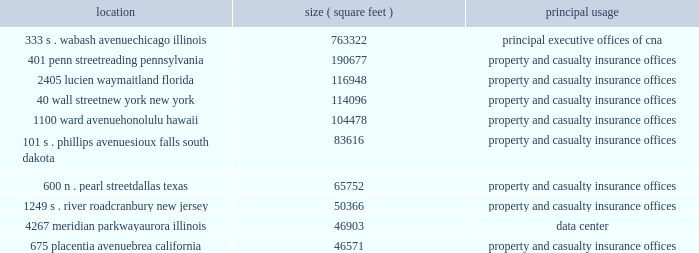Item 1 .
Business cna financial corporation 2013 ( continued ) unpredictability in the law , insurance underwriting is expected to continue to be difficult in commercial lines , professional liability and other specialty coverages .
The dodd-frank wall street reform and consumer protection act expands the federal presence in insurance oversight and may increase the regulatory requirements to which cna may be subject .
The act 2019s requirements include streamlining the state-based regulation of reinsurance and nonadmitted insurance ( property or casualty insurance placed from insurers that are eligible to accept insurance , but are not licensed to write insurance in a particular state ) .
The act also establishes a new federal insurance office within the u.s .
Department of the treasury with powers over all lines of insurance except health insurance , certain long term care insurance and crop insurance , to , among other things , monitor aspects of the insurance industry , identify issues in the regulation of insurers that could contribute to a systemic crisis in the insurance industry or the overall financial system , coordinate federal policy on international insurance matters and preempt state insurance measures under certain circumstances .
The act calls for numerous studies and contemplates further regulation .
The patient protection and affordable care act and the related amendments in the health care and education reconciliation act may increase cna 2019s operating costs and underwriting losses .
This landmark legislation may lead to numerous changes in the health care industry that could create additional operating costs for cna , particularly with respect to workers 2019 compensation and long term care products .
These costs might arise through the increased use of health care services by claimants or the increased complexities in health care bills that could require additional levels of review .
In addition , due to the expected number of new participants in the health care system and the potential for additional malpractice claims , cna may experience increased underwriting risk in the lines of business that provide management and professional liability insurance to individuals and businesses engaged in the health care industry .
The lines of business that provide professional liability insurance to attorneys , accountants and other professionals who advise clients regarding the health care reform legislation may also experience increased underwriting risk due to the complexity of the legislation .
Properties : the chicago location owned by ccc , a wholly owned subsidiary of cna , houses cna 2019s principal executive offices .
Cna owns or leases office space in various cities throughout the united states and in other countries .
The table sets forth certain information with respect to cna 2019s principal office locations : location ( square feet ) principal usage 333 s .
Wabash avenue 763322 principal executive offices of cna chicago , illinois 401 penn street 190677 property and casualty insurance offices reading , pennsylvania 2405 lucien way 116948 property and casualty insurance offices maitland , florida 40 wall street 114096 property and casualty insurance offices new york , new york 1100 ward avenue 104478 property and casualty insurance offices honolulu , hawaii 101 s .
Phillips avenue 83616 property and casualty insurance offices sioux falls , south dakota 600 n .
Pearl street 65752 property and casualty insurance offices dallas , texas 1249 s .
River road 50366 property and casualty insurance offices cranbury , new jersey 4267 meridian parkway 46903 data center aurora , illinois 675 placentia avenue 46571 property and casualty insurance offices brea , california cna leases its office space described above except for the chicago , illinois building , the reading , pennsylvania building , and the aurora , illinois building , which are owned. .
Item 1 .
Business cna financial corporation 2013 ( continued ) unpredictability in the law , insurance underwriting is expected to continue to be difficult in commercial lines , professional liability and other specialty coverages .
The dodd-frank wall street reform and consumer protection act expands the federal presence in insurance oversight and may increase the regulatory requirements to which cna may be subject .
The act 2019s requirements include streamlining the state-based regulation of reinsurance and nonadmitted insurance ( property or casualty insurance placed from insurers that are eligible to accept insurance , but are not licensed to write insurance in a particular state ) .
The act also establishes a new federal insurance office within the u.s .
Department of the treasury with powers over all lines of insurance except health insurance , certain long term care insurance and crop insurance , to , among other things , monitor aspects of the insurance industry , identify issues in the regulation of insurers that could contribute to a systemic crisis in the insurance industry or the overall financial system , coordinate federal policy on international insurance matters and preempt state insurance measures under certain circumstances .
The act calls for numerous studies and contemplates further regulation .
The patient protection and affordable care act and the related amendments in the health care and education reconciliation act may increase cna 2019s operating costs and underwriting losses .
This landmark legislation may lead to numerous changes in the health care industry that could create additional operating costs for cna , particularly with respect to workers 2019 compensation and long term care products .
These costs might arise through the increased use of health care services by claimants or the increased complexities in health care bills that could require additional levels of review .
In addition , due to the expected number of new participants in the health care system and the potential for additional malpractice claims , cna may experience increased underwriting risk in the lines of business that provide management and professional liability insurance to individuals and businesses engaged in the health care industry .
The lines of business that provide professional liability insurance to attorneys , accountants and other professionals who advise clients regarding the health care reform legislation may also experience increased underwriting risk due to the complexity of the legislation .
Properties : the chicago location owned by ccc , a wholly owned subsidiary of cna , houses cna 2019s principal executive offices .
Cna owns or leases office space in various cities throughout the united states and in other countries .
The following table sets forth certain information with respect to cna 2019s principal office locations : location ( square feet ) principal usage 333 s .
Wabash avenue 763322 principal executive offices of cna chicago , illinois 401 penn street 190677 property and casualty insurance offices reading , pennsylvania 2405 lucien way 116948 property and casualty insurance offices maitland , florida 40 wall street 114096 property and casualty insurance offices new york , new york 1100 ward avenue 104478 property and casualty insurance offices honolulu , hawaii 101 s .
Phillips avenue 83616 property and casualty insurance offices sioux falls , south dakota 600 n .
Pearl street 65752 property and casualty insurance offices dallas , texas 1249 s .
River road 50366 property and casualty insurance offices cranbury , new jersey 4267 meridian parkway 46903 data center aurora , illinois 675 placentia avenue 46571 property and casualty insurance offices brea , california cna leases its office space described above except for the chicago , illinois building , the reading , pennsylvania building , and the aurora , illinois building , which are owned. .
What percent of the illinois properties relate to data centers? 
Computations: (46903 / (46903 + 763322))
Answer: 0.05789. 